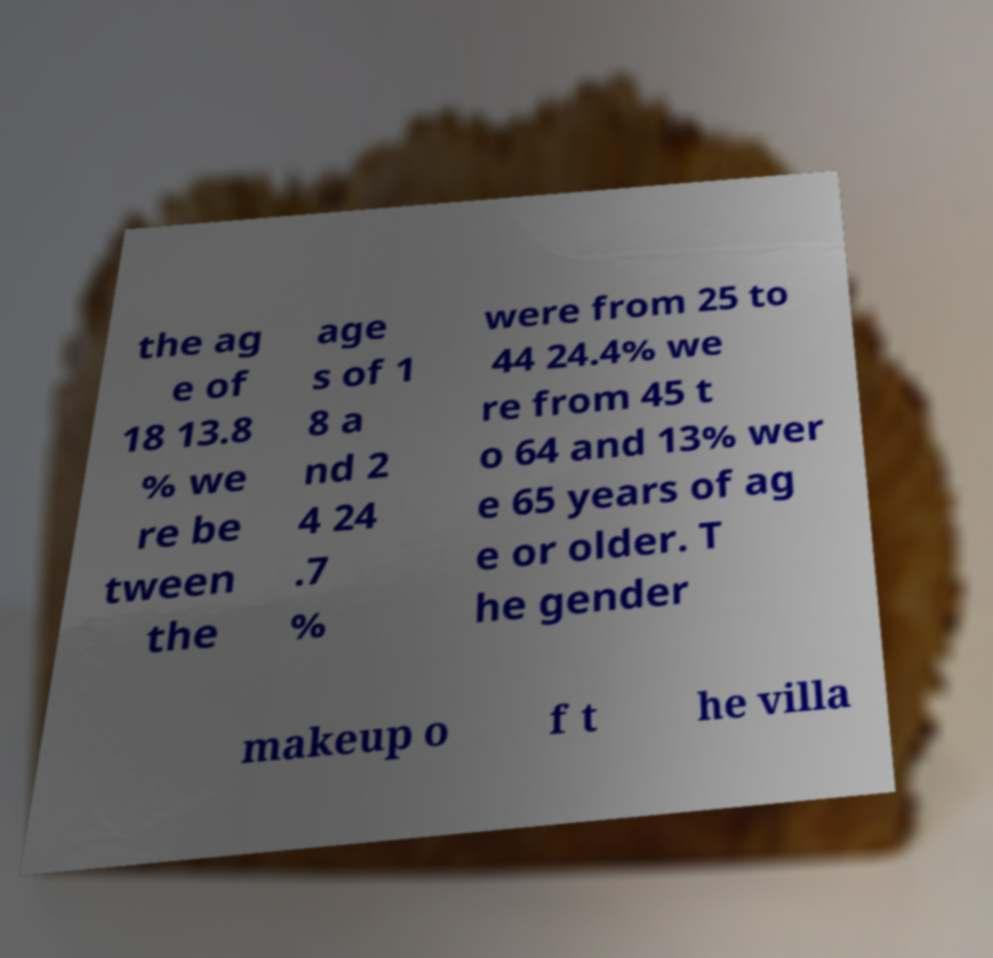I need the written content from this picture converted into text. Can you do that? the ag e of 18 13.8 % we re be tween the age s of 1 8 a nd 2 4 24 .7 % were from 25 to 44 24.4% we re from 45 t o 64 and 13% wer e 65 years of ag e or older. T he gender makeup o f t he villa 